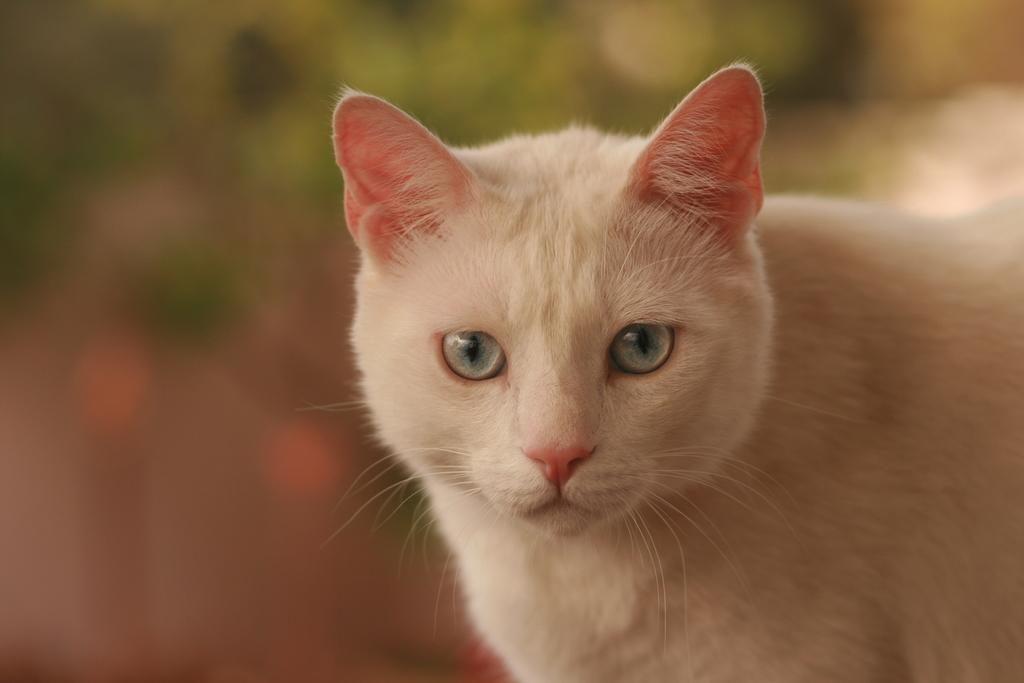What type of animal is in the image? There is a white cat in the image. Can you describe the background of the image? The background of the image is blurred. What type of berry is the farmer holding in the image? There is no farmer or berry present in the image; it features a white cat with a blurred background. 